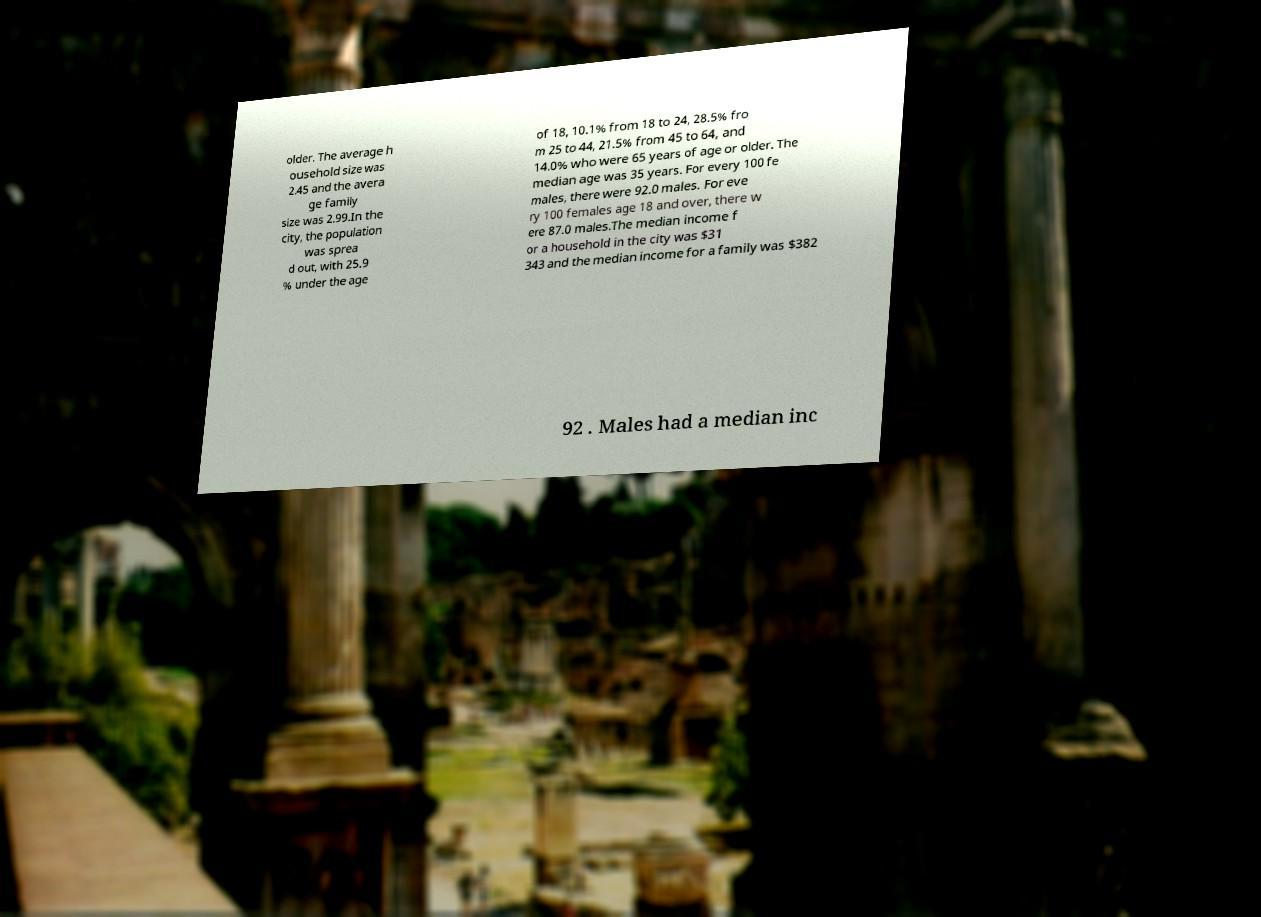I need the written content from this picture converted into text. Can you do that? older. The average h ousehold size was 2.45 and the avera ge family size was 2.99.In the city, the population was sprea d out, with 25.9 % under the age of 18, 10.1% from 18 to 24, 28.5% fro m 25 to 44, 21.5% from 45 to 64, and 14.0% who were 65 years of age or older. The median age was 35 years. For every 100 fe males, there were 92.0 males. For eve ry 100 females age 18 and over, there w ere 87.0 males.The median income f or a household in the city was $31 343 and the median income for a family was $382 92 . Males had a median inc 